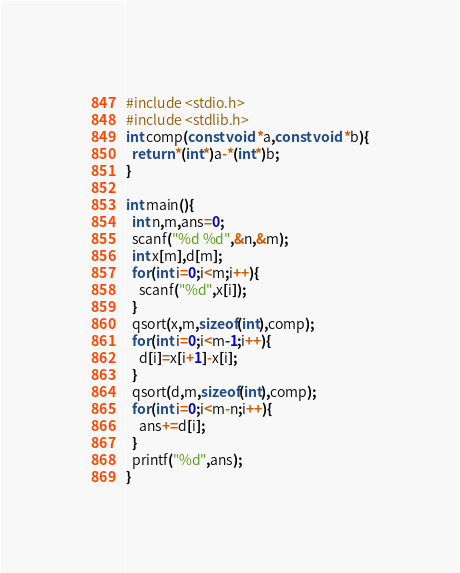<code> <loc_0><loc_0><loc_500><loc_500><_C_>#include <stdio.h>
#include <stdlib.h>
int comp(const void *a,const void *b){
  return *(int*)a-*(int*)b;
}

int main(){
  int n,m,ans=0;
  scanf("%d %d",&n,&m);
  int x[m],d[m];
  for(int i=0;i<m;i++){
    scanf("%d",x[i]);
  }
  qsort(x,m,sizeof(int),comp);
  for(int i=0;i<m-1;i++){
    d[i]=x[i+1]-x[i];
  }
  qsort(d,m,sizeof(int),comp);
  for(int i=0;i<m-n;i++){
    ans+=d[i];
  }
  printf("%d",ans);
}</code> 